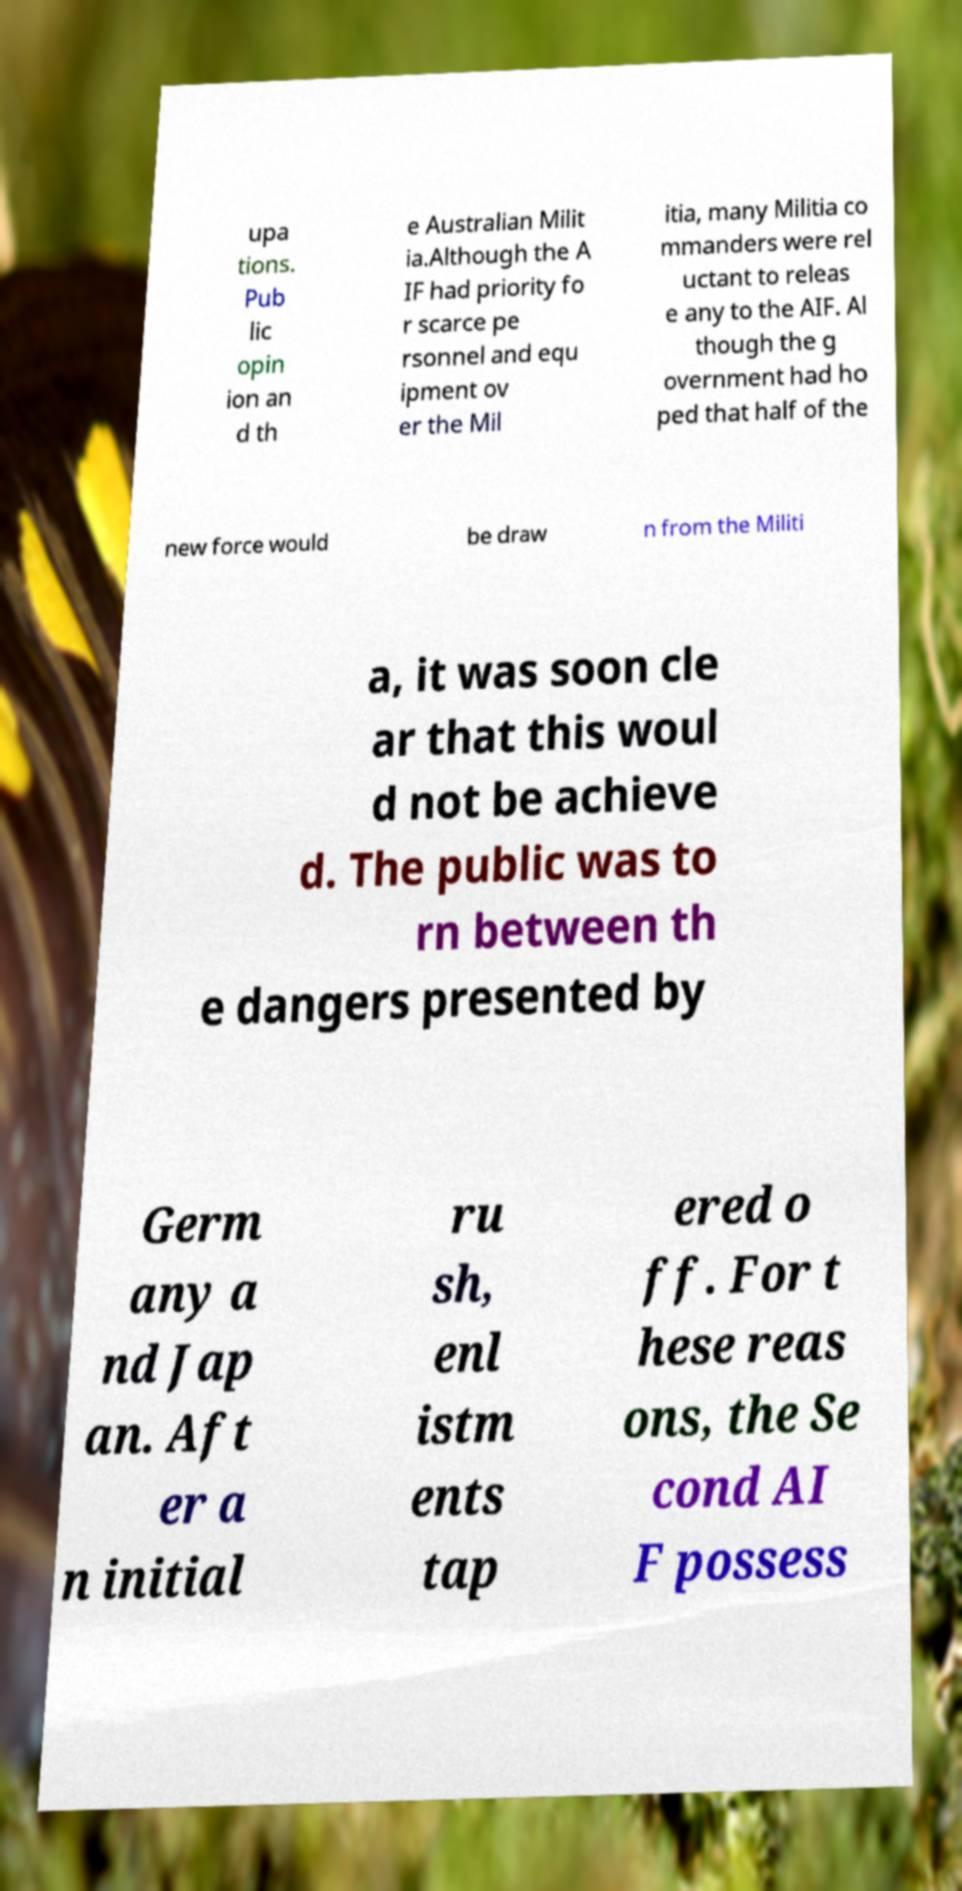Can you read and provide the text displayed in the image?This photo seems to have some interesting text. Can you extract and type it out for me? upa tions. Pub lic opin ion an d th e Australian Milit ia.Although the A IF had priority fo r scarce pe rsonnel and equ ipment ov er the Mil itia, many Militia co mmanders were rel uctant to releas e any to the AIF. Al though the g overnment had ho ped that half of the new force would be draw n from the Militi a, it was soon cle ar that this woul d not be achieve d. The public was to rn between th e dangers presented by Germ any a nd Jap an. Aft er a n initial ru sh, enl istm ents tap ered o ff. For t hese reas ons, the Se cond AI F possess 